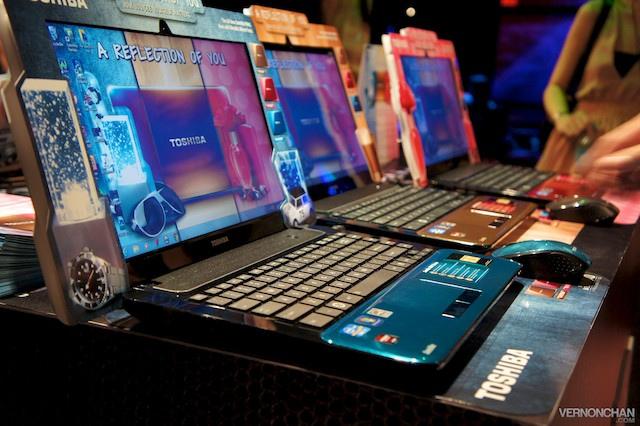What color are the computers?
Answer briefly. Black. How many computers are there?
Keep it brief. 3. Is a rainbow seen in the photo?
Write a very short answer. No. 